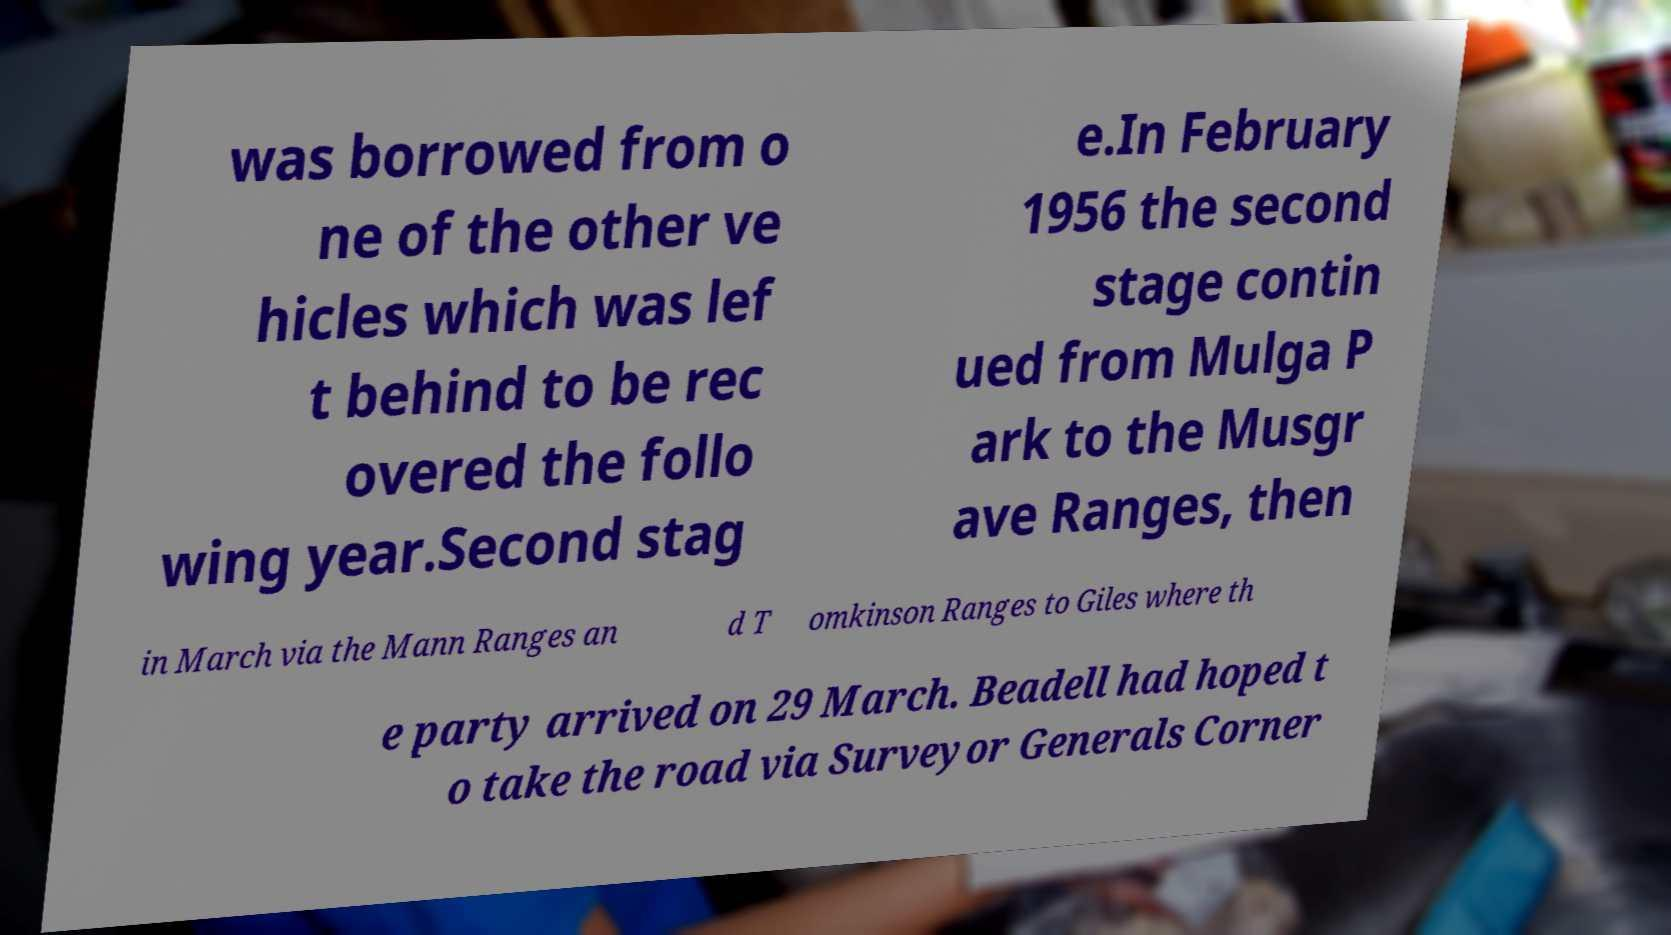There's text embedded in this image that I need extracted. Can you transcribe it verbatim? was borrowed from o ne of the other ve hicles which was lef t behind to be rec overed the follo wing year.Second stag e.In February 1956 the second stage contin ued from Mulga P ark to the Musgr ave Ranges, then in March via the Mann Ranges an d T omkinson Ranges to Giles where th e party arrived on 29 March. Beadell had hoped t o take the road via Surveyor Generals Corner 